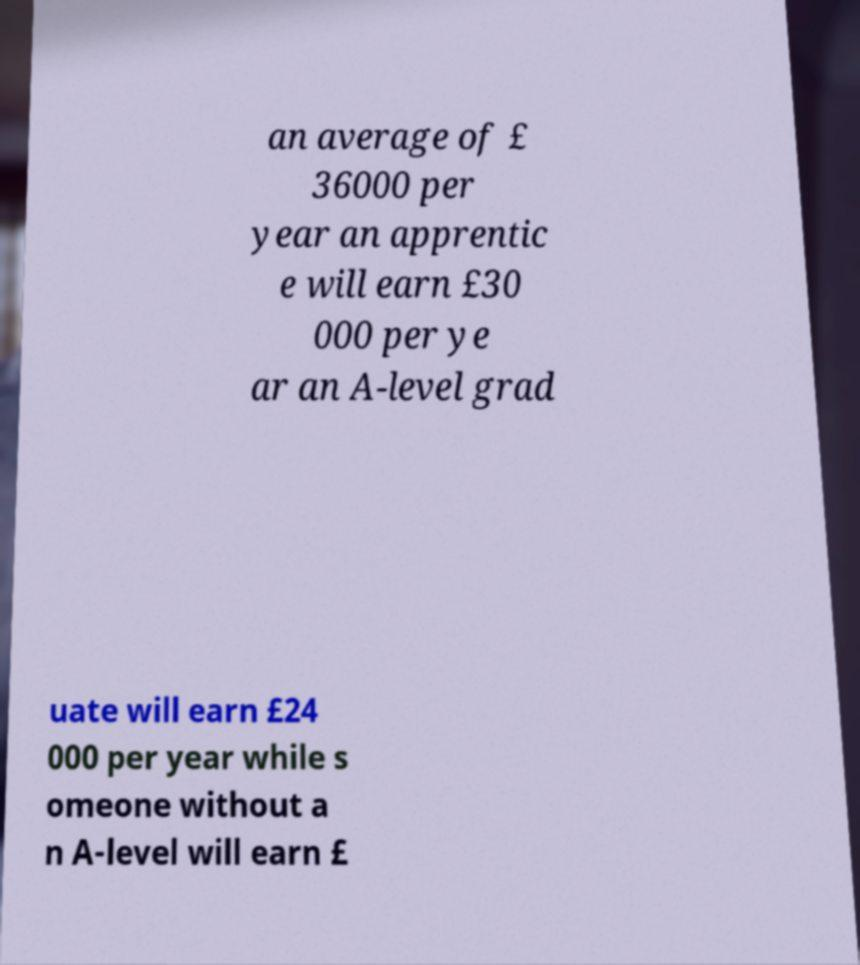Could you assist in decoding the text presented in this image and type it out clearly? an average of £ 36000 per year an apprentic e will earn £30 000 per ye ar an A-level grad uate will earn £24 000 per year while s omeone without a n A-level will earn £ 